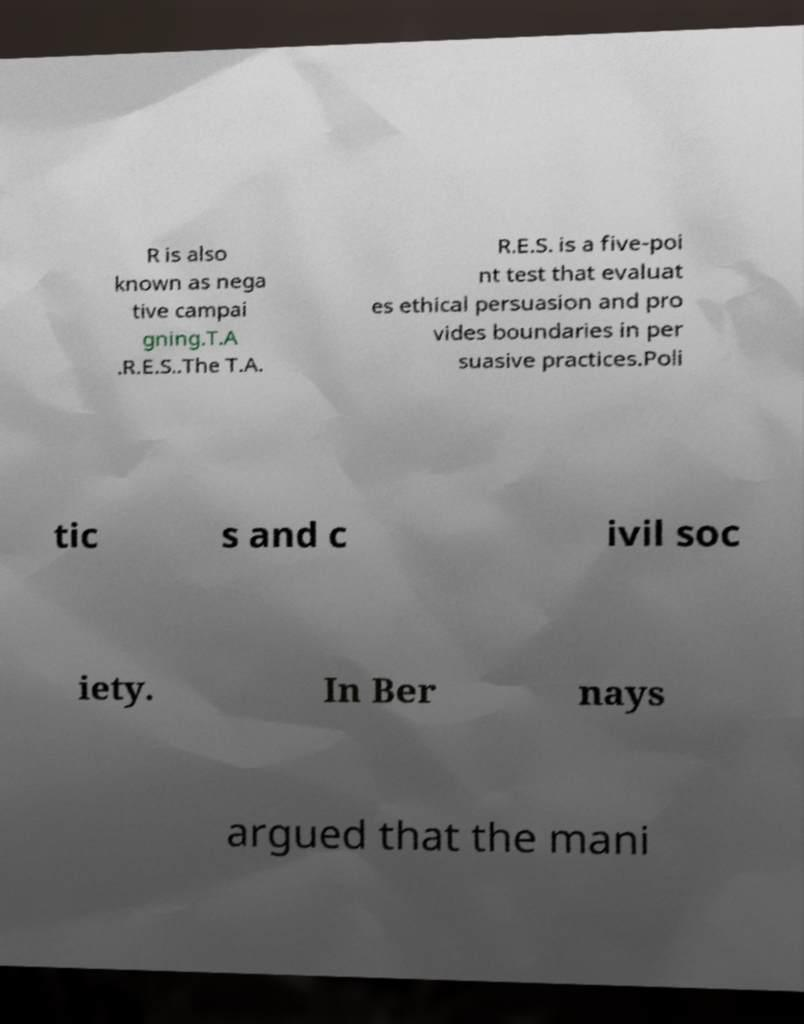Can you accurately transcribe the text from the provided image for me? R is also known as nega tive campai gning.T.A .R.E.S..The T.A. R.E.S. is a five-poi nt test that evaluat es ethical persuasion and pro vides boundaries in per suasive practices.Poli tic s and c ivil soc iety. In Ber nays argued that the mani 